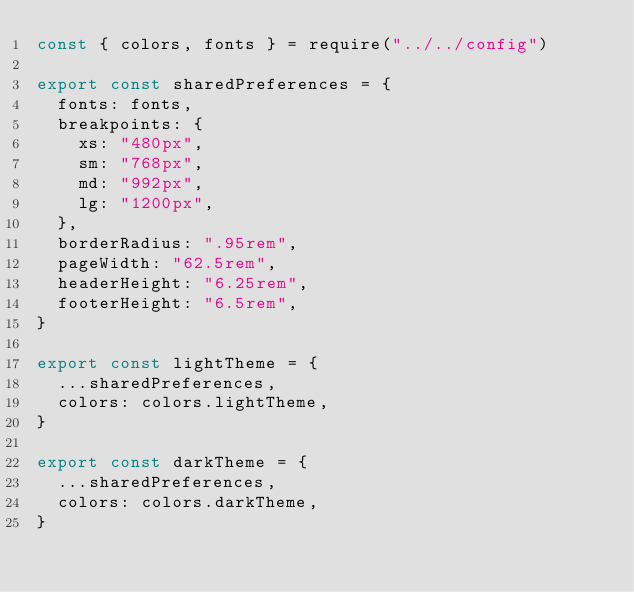Convert code to text. <code><loc_0><loc_0><loc_500><loc_500><_JavaScript_>const { colors, fonts } = require("../../config")

export const sharedPreferences = {
  fonts: fonts,
  breakpoints: {
    xs: "480px",
    sm: "768px",
    md: "992px",
    lg: "1200px",
  },
  borderRadius: ".95rem",
  pageWidth: "62.5rem",
  headerHeight: "6.25rem",
  footerHeight: "6.5rem",
}

export const lightTheme = {
  ...sharedPreferences,
  colors: colors.lightTheme,
}

export const darkTheme = {
  ...sharedPreferences,
  colors: colors.darkTheme,
}
</code> 